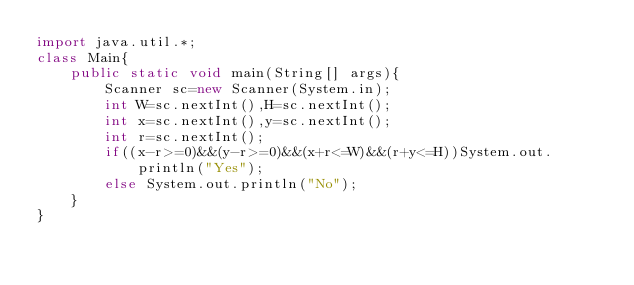<code> <loc_0><loc_0><loc_500><loc_500><_Java_>import java.util.*;
class Main{
    public static void main(String[] args){
        Scanner sc=new Scanner(System.in);
        int W=sc.nextInt(),H=sc.nextInt();
        int x=sc.nextInt(),y=sc.nextInt();
        int r=sc.nextInt();
        if((x-r>=0)&&(y-r>=0)&&(x+r<=W)&&(r+y<=H))System.out.println("Yes");
        else System.out.println("No");
    }
}</code> 